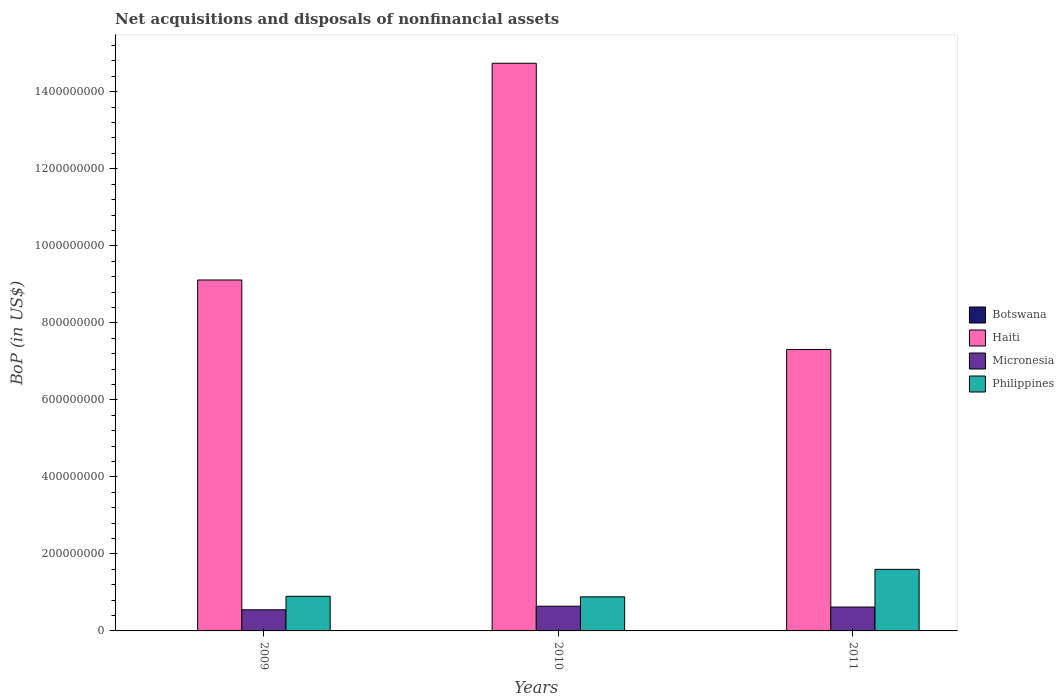How many different coloured bars are there?
Give a very brief answer. 4. Are the number of bars on each tick of the X-axis equal?
Give a very brief answer. No. How many bars are there on the 1st tick from the left?
Give a very brief answer. 3. What is the Balance of Payments in Botswana in 2011?
Your answer should be compact. 3.77e+05. Across all years, what is the maximum Balance of Payments in Micronesia?
Keep it short and to the point. 6.42e+07. Across all years, what is the minimum Balance of Payments in Micronesia?
Give a very brief answer. 5.49e+07. In which year was the Balance of Payments in Micronesia maximum?
Your answer should be very brief. 2010. What is the total Balance of Payments in Micronesia in the graph?
Your response must be concise. 1.81e+08. What is the difference between the Balance of Payments in Haiti in 2009 and that in 2011?
Keep it short and to the point. 1.80e+08. What is the difference between the Balance of Payments in Haiti in 2010 and the Balance of Payments in Philippines in 2009?
Ensure brevity in your answer.  1.38e+09. What is the average Balance of Payments in Micronesia per year?
Provide a short and direct response. 6.04e+07. In the year 2011, what is the difference between the Balance of Payments in Micronesia and Balance of Payments in Philippines?
Your answer should be very brief. -9.79e+07. In how many years, is the Balance of Payments in Philippines greater than 760000000 US$?
Your answer should be very brief. 0. What is the ratio of the Balance of Payments in Micronesia in 2009 to that in 2011?
Provide a short and direct response. 0.89. Is the Balance of Payments in Micronesia in 2010 less than that in 2011?
Make the answer very short. No. What is the difference between the highest and the second highest Balance of Payments in Haiti?
Make the answer very short. 5.63e+08. What is the difference between the highest and the lowest Balance of Payments in Micronesia?
Offer a very short reply. 9.31e+06. In how many years, is the Balance of Payments in Botswana greater than the average Balance of Payments in Botswana taken over all years?
Provide a short and direct response. 1. Is it the case that in every year, the sum of the Balance of Payments in Botswana and Balance of Payments in Haiti is greater than the sum of Balance of Payments in Micronesia and Balance of Payments in Philippines?
Ensure brevity in your answer.  Yes. Is it the case that in every year, the sum of the Balance of Payments in Philippines and Balance of Payments in Haiti is greater than the Balance of Payments in Botswana?
Provide a succinct answer. Yes. How many bars are there?
Keep it short and to the point. 10. Are the values on the major ticks of Y-axis written in scientific E-notation?
Ensure brevity in your answer.  No. Does the graph contain any zero values?
Your response must be concise. Yes. What is the title of the graph?
Keep it short and to the point. Net acquisitions and disposals of nonfinancial assets. What is the label or title of the X-axis?
Keep it short and to the point. Years. What is the label or title of the Y-axis?
Provide a succinct answer. BoP (in US$). What is the BoP (in US$) of Botswana in 2009?
Your answer should be very brief. 0. What is the BoP (in US$) of Haiti in 2009?
Your response must be concise. 9.11e+08. What is the BoP (in US$) in Micronesia in 2009?
Offer a very short reply. 5.49e+07. What is the BoP (in US$) of Philippines in 2009?
Provide a succinct answer. 8.99e+07. What is the BoP (in US$) of Botswana in 2010?
Your answer should be compact. 0. What is the BoP (in US$) of Haiti in 2010?
Ensure brevity in your answer.  1.47e+09. What is the BoP (in US$) of Micronesia in 2010?
Provide a short and direct response. 6.42e+07. What is the BoP (in US$) of Philippines in 2010?
Offer a terse response. 8.85e+07. What is the BoP (in US$) in Botswana in 2011?
Your response must be concise. 3.77e+05. What is the BoP (in US$) of Haiti in 2011?
Offer a terse response. 7.31e+08. What is the BoP (in US$) in Micronesia in 2011?
Provide a short and direct response. 6.20e+07. What is the BoP (in US$) in Philippines in 2011?
Give a very brief answer. 1.60e+08. Across all years, what is the maximum BoP (in US$) of Botswana?
Ensure brevity in your answer.  3.77e+05. Across all years, what is the maximum BoP (in US$) of Haiti?
Offer a very short reply. 1.47e+09. Across all years, what is the maximum BoP (in US$) of Micronesia?
Offer a very short reply. 6.42e+07. Across all years, what is the maximum BoP (in US$) of Philippines?
Offer a very short reply. 1.60e+08. Across all years, what is the minimum BoP (in US$) of Botswana?
Your answer should be compact. 0. Across all years, what is the minimum BoP (in US$) of Haiti?
Your response must be concise. 7.31e+08. Across all years, what is the minimum BoP (in US$) in Micronesia?
Make the answer very short. 5.49e+07. Across all years, what is the minimum BoP (in US$) of Philippines?
Your response must be concise. 8.85e+07. What is the total BoP (in US$) in Botswana in the graph?
Keep it short and to the point. 3.77e+05. What is the total BoP (in US$) in Haiti in the graph?
Your response must be concise. 3.12e+09. What is the total BoP (in US$) in Micronesia in the graph?
Provide a short and direct response. 1.81e+08. What is the total BoP (in US$) of Philippines in the graph?
Your answer should be very brief. 3.38e+08. What is the difference between the BoP (in US$) of Haiti in 2009 and that in 2010?
Make the answer very short. -5.63e+08. What is the difference between the BoP (in US$) of Micronesia in 2009 and that in 2010?
Give a very brief answer. -9.31e+06. What is the difference between the BoP (in US$) of Philippines in 2009 and that in 2010?
Your answer should be compact. 1.39e+06. What is the difference between the BoP (in US$) of Haiti in 2009 and that in 2011?
Make the answer very short. 1.80e+08. What is the difference between the BoP (in US$) in Micronesia in 2009 and that in 2011?
Ensure brevity in your answer.  -7.10e+06. What is the difference between the BoP (in US$) in Philippines in 2009 and that in 2011?
Offer a very short reply. -7.00e+07. What is the difference between the BoP (in US$) of Haiti in 2010 and that in 2011?
Make the answer very short. 7.43e+08. What is the difference between the BoP (in US$) of Micronesia in 2010 and that in 2011?
Your answer should be compact. 2.21e+06. What is the difference between the BoP (in US$) in Philippines in 2010 and that in 2011?
Ensure brevity in your answer.  -7.14e+07. What is the difference between the BoP (in US$) in Haiti in 2009 and the BoP (in US$) in Micronesia in 2010?
Your response must be concise. 8.47e+08. What is the difference between the BoP (in US$) in Haiti in 2009 and the BoP (in US$) in Philippines in 2010?
Keep it short and to the point. 8.23e+08. What is the difference between the BoP (in US$) in Micronesia in 2009 and the BoP (in US$) in Philippines in 2010?
Make the answer very short. -3.36e+07. What is the difference between the BoP (in US$) of Haiti in 2009 and the BoP (in US$) of Micronesia in 2011?
Provide a short and direct response. 8.49e+08. What is the difference between the BoP (in US$) in Haiti in 2009 and the BoP (in US$) in Philippines in 2011?
Offer a very short reply. 7.51e+08. What is the difference between the BoP (in US$) of Micronesia in 2009 and the BoP (in US$) of Philippines in 2011?
Your answer should be very brief. -1.05e+08. What is the difference between the BoP (in US$) in Haiti in 2010 and the BoP (in US$) in Micronesia in 2011?
Keep it short and to the point. 1.41e+09. What is the difference between the BoP (in US$) in Haiti in 2010 and the BoP (in US$) in Philippines in 2011?
Give a very brief answer. 1.31e+09. What is the difference between the BoP (in US$) of Micronesia in 2010 and the BoP (in US$) of Philippines in 2011?
Provide a short and direct response. -9.57e+07. What is the average BoP (in US$) in Botswana per year?
Offer a terse response. 1.26e+05. What is the average BoP (in US$) of Haiti per year?
Offer a very short reply. 1.04e+09. What is the average BoP (in US$) in Micronesia per year?
Keep it short and to the point. 6.04e+07. What is the average BoP (in US$) in Philippines per year?
Make the answer very short. 1.13e+08. In the year 2009, what is the difference between the BoP (in US$) of Haiti and BoP (in US$) of Micronesia?
Provide a short and direct response. 8.56e+08. In the year 2009, what is the difference between the BoP (in US$) in Haiti and BoP (in US$) in Philippines?
Provide a short and direct response. 8.21e+08. In the year 2009, what is the difference between the BoP (in US$) of Micronesia and BoP (in US$) of Philippines?
Your response must be concise. -3.50e+07. In the year 2010, what is the difference between the BoP (in US$) of Haiti and BoP (in US$) of Micronesia?
Ensure brevity in your answer.  1.41e+09. In the year 2010, what is the difference between the BoP (in US$) of Haiti and BoP (in US$) of Philippines?
Your answer should be compact. 1.39e+09. In the year 2010, what is the difference between the BoP (in US$) of Micronesia and BoP (in US$) of Philippines?
Keep it short and to the point. -2.43e+07. In the year 2011, what is the difference between the BoP (in US$) of Botswana and BoP (in US$) of Haiti?
Ensure brevity in your answer.  -7.30e+08. In the year 2011, what is the difference between the BoP (in US$) of Botswana and BoP (in US$) of Micronesia?
Give a very brief answer. -6.16e+07. In the year 2011, what is the difference between the BoP (in US$) in Botswana and BoP (in US$) in Philippines?
Offer a terse response. -1.60e+08. In the year 2011, what is the difference between the BoP (in US$) in Haiti and BoP (in US$) in Micronesia?
Your response must be concise. 6.69e+08. In the year 2011, what is the difference between the BoP (in US$) in Haiti and BoP (in US$) in Philippines?
Your answer should be very brief. 5.71e+08. In the year 2011, what is the difference between the BoP (in US$) of Micronesia and BoP (in US$) of Philippines?
Provide a succinct answer. -9.79e+07. What is the ratio of the BoP (in US$) of Haiti in 2009 to that in 2010?
Provide a succinct answer. 0.62. What is the ratio of the BoP (in US$) in Micronesia in 2009 to that in 2010?
Make the answer very short. 0.85. What is the ratio of the BoP (in US$) of Philippines in 2009 to that in 2010?
Your answer should be compact. 1.02. What is the ratio of the BoP (in US$) in Haiti in 2009 to that in 2011?
Offer a terse response. 1.25. What is the ratio of the BoP (in US$) of Micronesia in 2009 to that in 2011?
Offer a terse response. 0.89. What is the ratio of the BoP (in US$) in Philippines in 2009 to that in 2011?
Your answer should be very brief. 0.56. What is the ratio of the BoP (in US$) of Haiti in 2010 to that in 2011?
Keep it short and to the point. 2.02. What is the ratio of the BoP (in US$) in Micronesia in 2010 to that in 2011?
Offer a terse response. 1.04. What is the ratio of the BoP (in US$) in Philippines in 2010 to that in 2011?
Offer a very short reply. 0.55. What is the difference between the highest and the second highest BoP (in US$) in Haiti?
Make the answer very short. 5.63e+08. What is the difference between the highest and the second highest BoP (in US$) of Micronesia?
Your answer should be very brief. 2.21e+06. What is the difference between the highest and the second highest BoP (in US$) of Philippines?
Your answer should be compact. 7.00e+07. What is the difference between the highest and the lowest BoP (in US$) in Botswana?
Your answer should be compact. 3.77e+05. What is the difference between the highest and the lowest BoP (in US$) of Haiti?
Ensure brevity in your answer.  7.43e+08. What is the difference between the highest and the lowest BoP (in US$) of Micronesia?
Offer a very short reply. 9.31e+06. What is the difference between the highest and the lowest BoP (in US$) of Philippines?
Give a very brief answer. 7.14e+07. 